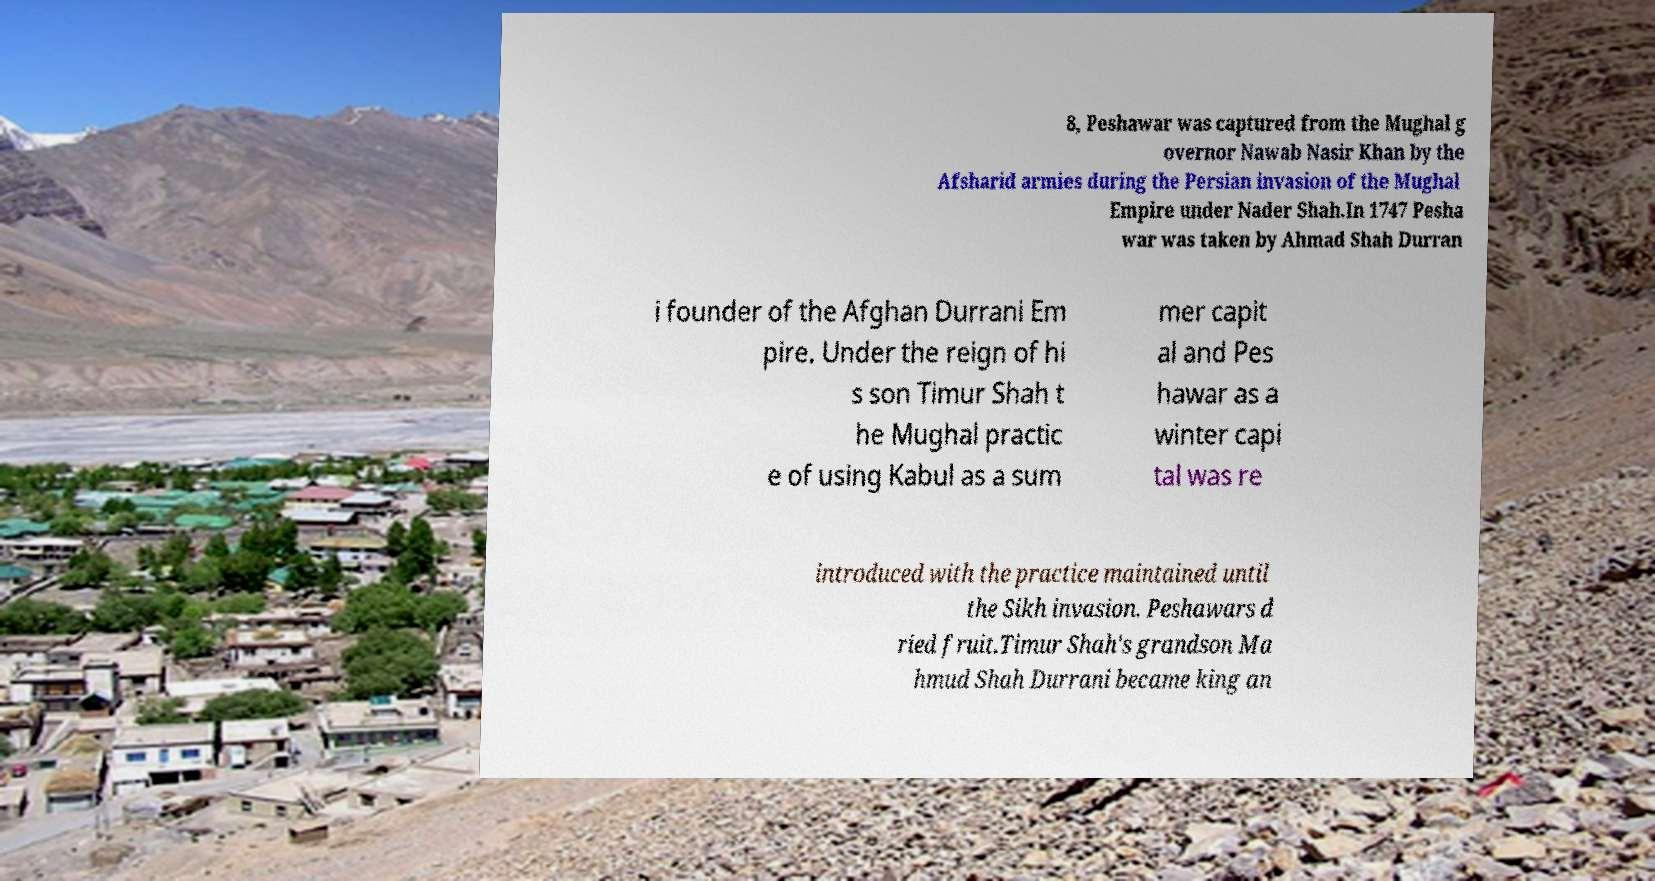Can you accurately transcribe the text from the provided image for me? 8, Peshawar was captured from the Mughal g overnor Nawab Nasir Khan by the Afsharid armies during the Persian invasion of the Mughal Empire under Nader Shah.In 1747 Pesha war was taken by Ahmad Shah Durran i founder of the Afghan Durrani Em pire. Under the reign of hi s son Timur Shah t he Mughal practic e of using Kabul as a sum mer capit al and Pes hawar as a winter capi tal was re introduced with the practice maintained until the Sikh invasion. Peshawars d ried fruit.Timur Shah's grandson Ma hmud Shah Durrani became king an 